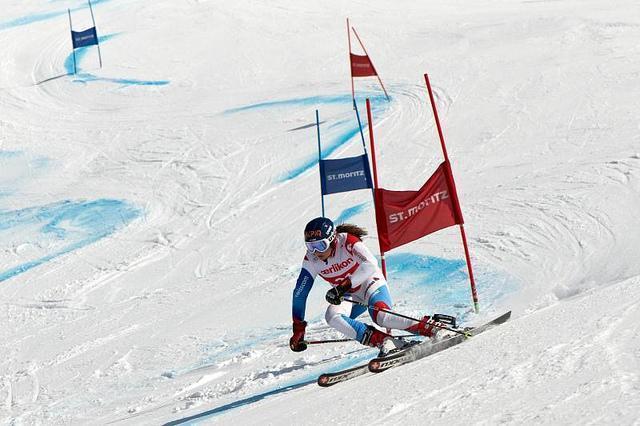How many poles?
Give a very brief answer. 2. How many people can be seen?
Give a very brief answer. 1. 